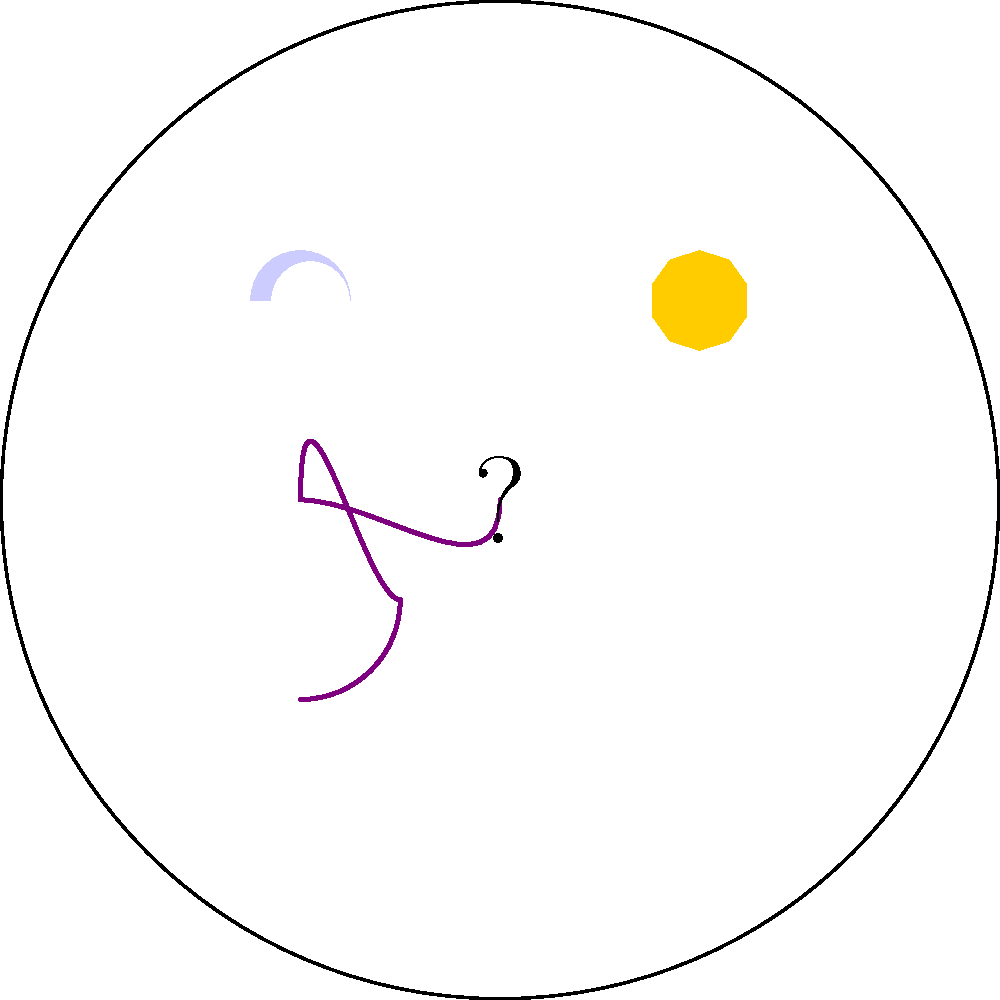Interpret the crystal ball's symbols to reveal your artistic destiny. Which element represents the transformative power that will guide your creative journey? To interpret the crystal ball's symbols and determine the transformative power for your artistic journey, let's analyze each element:

1. Star (top right): Often symbolizes hope, inspiration, and guidance. In artistic contexts, it can represent a breakthrough or moment of creative clarity.

2. Moon (top left): Typically associated with intuition, emotions, and the subconscious. For an artist, this could signify tapping into deeper, hidden aspects of creativity.

3. Spiral (bottom left): Represents growth, evolution, and transformation. In artistic terms, it suggests a journey of continuous development and exploration of new styles or techniques.

4. Question mark (center): Indicates mystery, uncertainty, and the need for introspection. For an artist, this could mean embracing the unknown and using it as a source of inspiration.

Given your persona as a troubled artist seeking guidance, the spiral is the most fitting symbol for transformative power. It suggests an ongoing process of growth and change, which aligns with the idea of finding solace and direction through the fortune teller's guidance. The spiral's continuous nature implies that your artistic journey will be one of constant evolution and discovery, helping you overcome your troubles through creative exploration and development.
Answer: Spiral 